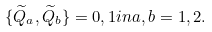Convert formula to latex. <formula><loc_0><loc_0><loc_500><loc_500>\{ \widetilde { Q } _ { a } , \widetilde { Q } _ { b } \} = 0 , 1 i n a , b = 1 , 2 .</formula> 